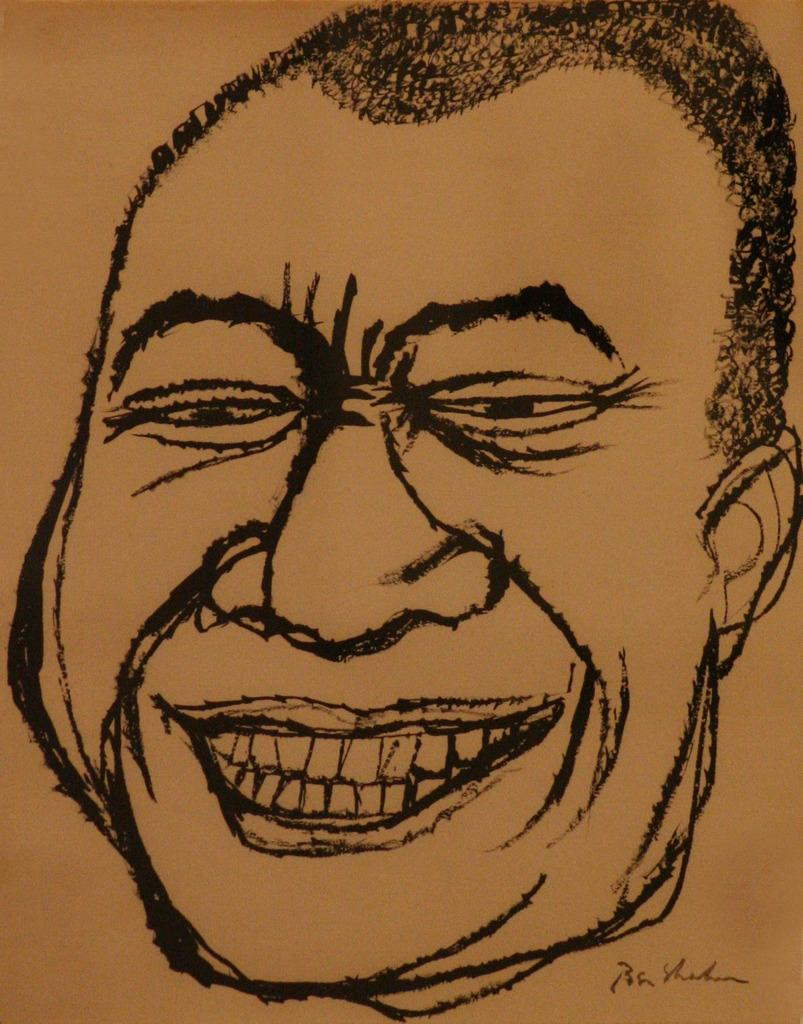What is the main subject of the image? There is an art piece in the image. What does the art piece depict? The art piece depicts a person's face. What material is the art piece created on? The art is on a paper. What color is the art piece? The art is in black color. What type of scent can be detected from the art piece in the image? There is no scent associated with the art piece in the image, as it is a visual representation on paper. 